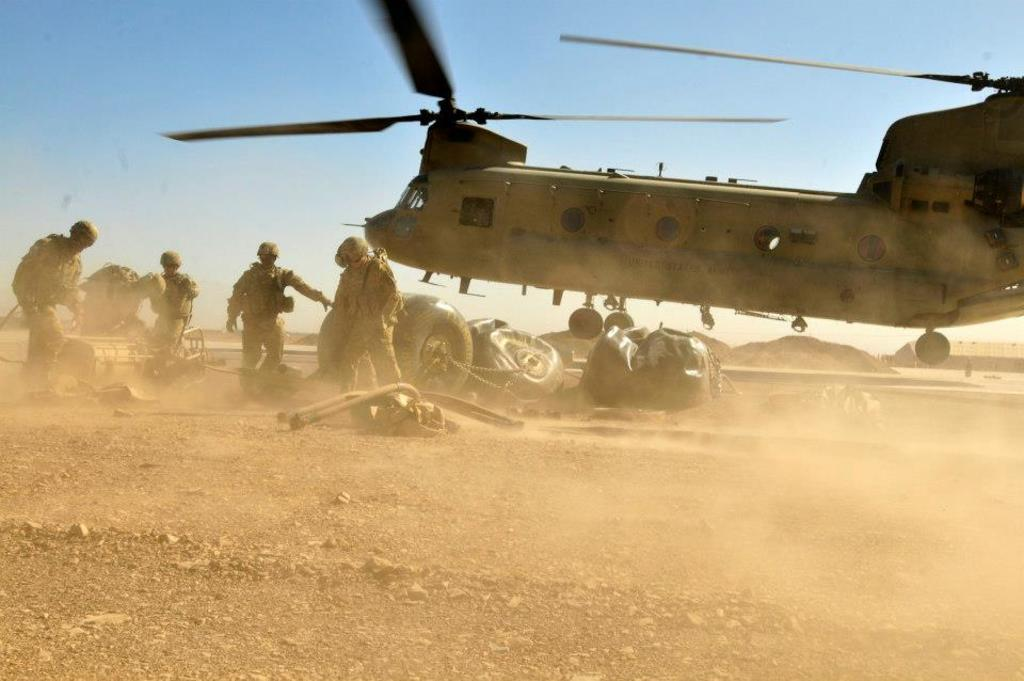What is the main subject of the image? The main subject of the image is a military helicopter flying. What else can be seen in the image besides the helicopter? There is a group of people standing and items on the ground in the image. What is visible in the background of the image? There is a house and the sky visible in the background of the image. Can you tell me how many times the helicopter folds its wings in the image? Helicopters do not have folding wings, so this detail cannot be observed in the image. Is there a volcano visible in the background of the image? No, there is no volcano present in the image; only a house and the sky are visible in the background. 